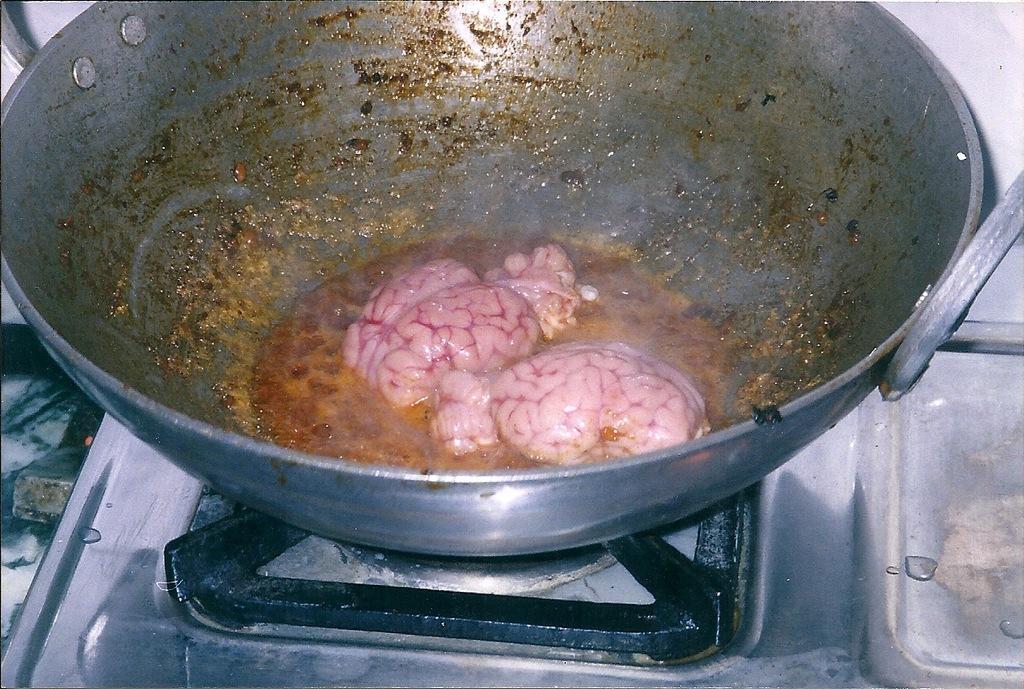Describe this image in one or two sentences. In this image we can see some food containing the brain in a vessel which is placed on a stove. 